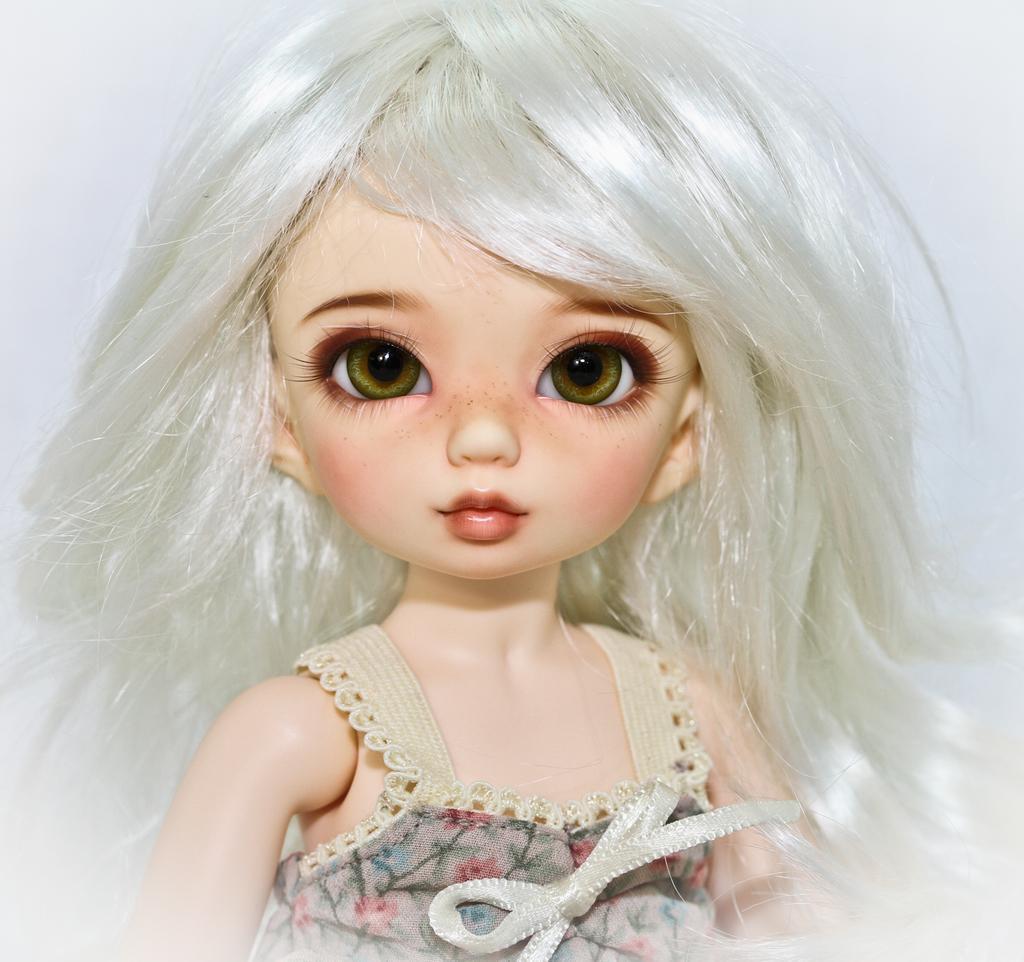Please provide a concise description of this image. In this picture I can see a doll, and there is white background. 